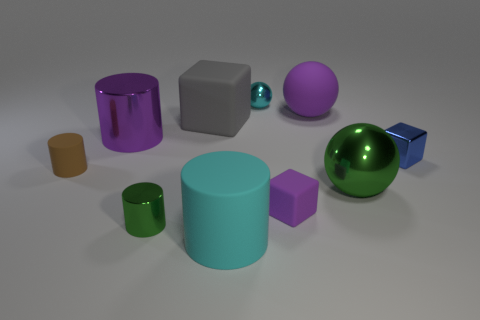What is the color of the small metal cube?
Your answer should be very brief. Blue. The metallic ball in front of the cyan metallic object that is behind the small cylinder on the left side of the green cylinder is what color?
Provide a short and direct response. Green. There is a blue metallic object; does it have the same shape as the large metallic thing in front of the tiny brown cylinder?
Keep it short and to the point. No. There is a tiny metal thing that is both behind the small purple cube and left of the tiny purple rubber object; what is its color?
Offer a terse response. Cyan. Are there any tiny objects that have the same shape as the big green metal object?
Offer a terse response. Yes. Is the small matte block the same color as the rubber sphere?
Your answer should be compact. Yes. Are there any green metal spheres that are behind the purple matte object that is behind the blue cube?
Give a very brief answer. No. What number of objects are small metallic objects to the left of the cyan metal ball or large shiny things to the right of the green cylinder?
Your answer should be compact. 2. What number of things are either green cylinders or big metal objects that are to the right of the cyan sphere?
Keep it short and to the point. 2. There is a matte block that is in front of the large object that is on the left side of the tiny cylinder on the right side of the small rubber cylinder; what size is it?
Offer a terse response. Small. 